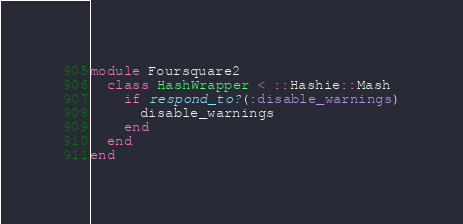Convert code to text. <code><loc_0><loc_0><loc_500><loc_500><_Ruby_>module Foursquare2
  class HashWrapper < ::Hashie::Mash
    if respond_to?(:disable_warnings)
      disable_warnings
    end
  end
end
</code> 